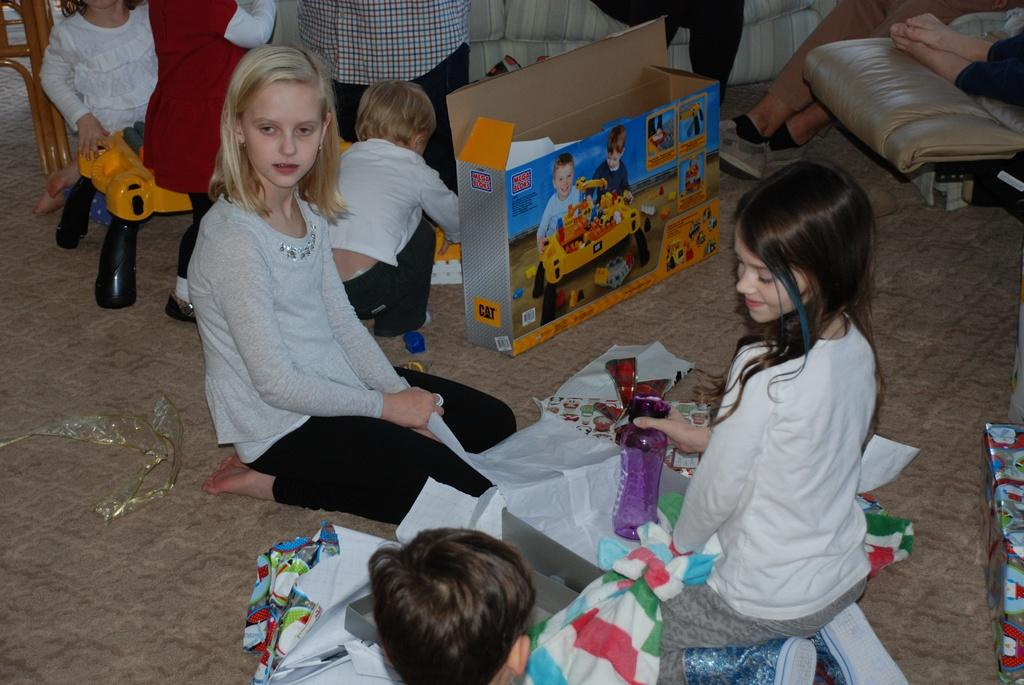How many people are present in the image? There is a group of people in the image, but the exact number cannot be determined from the provided facts. What items can be seen in the image besides the people? There are papers, toys, a cardboard box, and a couch visible in the image. What might be used for writing or reading in the image? Papers can be used for writing or reading in the image. What object might be used for storage or organization in the image? The cardboard box might be used for storage or organization in the image. What type of zinc is being used to cook the stew in the image? There is no zinc or stew present in the image; it features a group of people, papers, toys, a cardboard box, and a couch. What color is the paint on the wall behind the couch in the image? The provided facts do not mention any paint or wall behind the couch, so we cannot determine the color of the paint. 